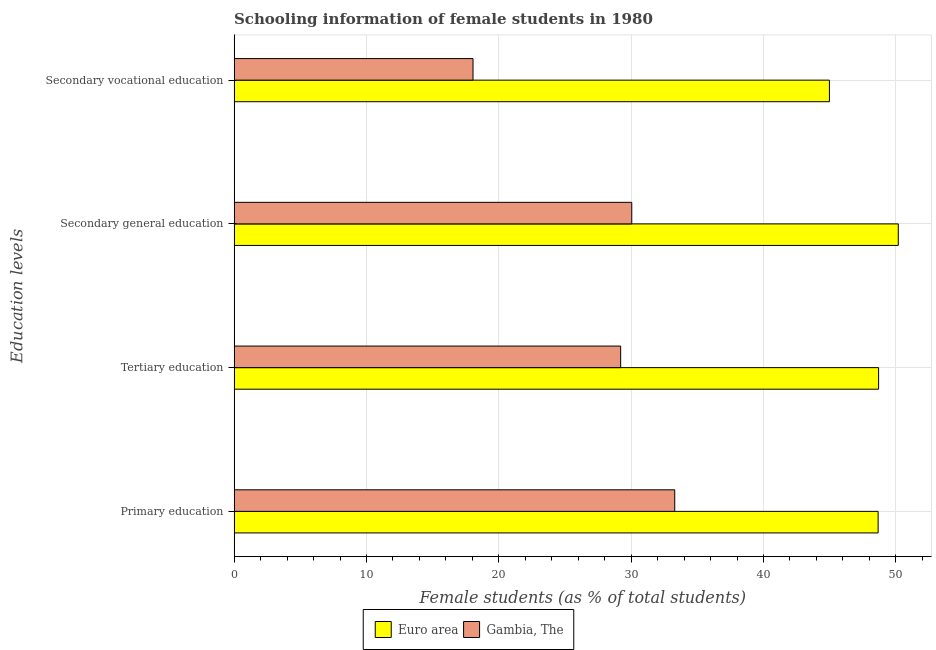How many different coloured bars are there?
Give a very brief answer. 2. How many groups of bars are there?
Offer a very short reply. 4. Are the number of bars per tick equal to the number of legend labels?
Give a very brief answer. Yes. How many bars are there on the 1st tick from the top?
Offer a terse response. 2. How many bars are there on the 4th tick from the bottom?
Provide a succinct answer. 2. What is the label of the 3rd group of bars from the top?
Provide a short and direct response. Tertiary education. What is the percentage of female students in primary education in Euro area?
Your answer should be very brief. 48.66. Across all countries, what is the maximum percentage of female students in secondary education?
Provide a succinct answer. 50.18. Across all countries, what is the minimum percentage of female students in secondary education?
Provide a succinct answer. 30.05. In which country was the percentage of female students in primary education minimum?
Your answer should be very brief. Gambia, The. What is the total percentage of female students in secondary vocational education in the graph?
Your answer should be very brief. 63.03. What is the difference between the percentage of female students in tertiary education in Euro area and that in Gambia, The?
Offer a very short reply. 19.49. What is the difference between the percentage of female students in primary education in Gambia, The and the percentage of female students in secondary education in Euro area?
Offer a very short reply. -16.89. What is the average percentage of female students in secondary vocational education per country?
Make the answer very short. 31.52. What is the difference between the percentage of female students in secondary vocational education and percentage of female students in primary education in Euro area?
Provide a short and direct response. -3.68. What is the ratio of the percentage of female students in tertiary education in Euro area to that in Gambia, The?
Offer a terse response. 1.67. Is the percentage of female students in tertiary education in Gambia, The less than that in Euro area?
Your answer should be compact. Yes. Is the difference between the percentage of female students in tertiary education in Gambia, The and Euro area greater than the difference between the percentage of female students in secondary vocational education in Gambia, The and Euro area?
Keep it short and to the point. Yes. What is the difference between the highest and the second highest percentage of female students in secondary education?
Keep it short and to the point. 20.14. What is the difference between the highest and the lowest percentage of female students in primary education?
Make the answer very short. 15.37. Is the sum of the percentage of female students in tertiary education in Euro area and Gambia, The greater than the maximum percentage of female students in primary education across all countries?
Your answer should be very brief. Yes. Is it the case that in every country, the sum of the percentage of female students in secondary education and percentage of female students in primary education is greater than the sum of percentage of female students in secondary vocational education and percentage of female students in tertiary education?
Provide a short and direct response. Yes. What does the 1st bar from the top in Secondary vocational education represents?
Ensure brevity in your answer.  Gambia, The. What does the 2nd bar from the bottom in Primary education represents?
Make the answer very short. Gambia, The. How many bars are there?
Your answer should be very brief. 8. Does the graph contain any zero values?
Your answer should be very brief. No. What is the title of the graph?
Your response must be concise. Schooling information of female students in 1980. Does "Pakistan" appear as one of the legend labels in the graph?
Ensure brevity in your answer.  No. What is the label or title of the X-axis?
Ensure brevity in your answer.  Female students (as % of total students). What is the label or title of the Y-axis?
Your response must be concise. Education levels. What is the Female students (as % of total students) in Euro area in Primary education?
Provide a short and direct response. 48.66. What is the Female students (as % of total students) in Gambia, The in Primary education?
Your answer should be compact. 33.29. What is the Female students (as % of total students) of Euro area in Tertiary education?
Your response must be concise. 48.7. What is the Female students (as % of total students) in Gambia, The in Tertiary education?
Provide a short and direct response. 29.21. What is the Female students (as % of total students) in Euro area in Secondary general education?
Give a very brief answer. 50.18. What is the Female students (as % of total students) of Gambia, The in Secondary general education?
Your response must be concise. 30.05. What is the Female students (as % of total students) in Euro area in Secondary vocational education?
Give a very brief answer. 44.98. What is the Female students (as % of total students) of Gambia, The in Secondary vocational education?
Make the answer very short. 18.05. Across all Education levels, what is the maximum Female students (as % of total students) in Euro area?
Ensure brevity in your answer.  50.18. Across all Education levels, what is the maximum Female students (as % of total students) of Gambia, The?
Provide a succinct answer. 33.29. Across all Education levels, what is the minimum Female students (as % of total students) of Euro area?
Provide a short and direct response. 44.98. Across all Education levels, what is the minimum Female students (as % of total students) in Gambia, The?
Your answer should be compact. 18.05. What is the total Female students (as % of total students) in Euro area in the graph?
Make the answer very short. 192.52. What is the total Female students (as % of total students) in Gambia, The in the graph?
Offer a very short reply. 110.6. What is the difference between the Female students (as % of total students) in Euro area in Primary education and that in Tertiary education?
Your answer should be compact. -0.03. What is the difference between the Female students (as % of total students) in Gambia, The in Primary education and that in Tertiary education?
Offer a terse response. 4.09. What is the difference between the Female students (as % of total students) in Euro area in Primary education and that in Secondary general education?
Ensure brevity in your answer.  -1.52. What is the difference between the Female students (as % of total students) of Gambia, The in Primary education and that in Secondary general education?
Provide a succinct answer. 3.25. What is the difference between the Female students (as % of total students) of Euro area in Primary education and that in Secondary vocational education?
Your answer should be compact. 3.68. What is the difference between the Female students (as % of total students) in Gambia, The in Primary education and that in Secondary vocational education?
Make the answer very short. 15.24. What is the difference between the Female students (as % of total students) in Euro area in Tertiary education and that in Secondary general education?
Give a very brief answer. -1.49. What is the difference between the Female students (as % of total students) in Gambia, The in Tertiary education and that in Secondary general education?
Give a very brief answer. -0.84. What is the difference between the Female students (as % of total students) in Euro area in Tertiary education and that in Secondary vocational education?
Offer a very short reply. 3.72. What is the difference between the Female students (as % of total students) in Gambia, The in Tertiary education and that in Secondary vocational education?
Ensure brevity in your answer.  11.15. What is the difference between the Female students (as % of total students) of Euro area in Secondary general education and that in Secondary vocational education?
Give a very brief answer. 5.2. What is the difference between the Female students (as % of total students) in Gambia, The in Secondary general education and that in Secondary vocational education?
Your answer should be very brief. 11.99. What is the difference between the Female students (as % of total students) of Euro area in Primary education and the Female students (as % of total students) of Gambia, The in Tertiary education?
Offer a very short reply. 19.46. What is the difference between the Female students (as % of total students) in Euro area in Primary education and the Female students (as % of total students) in Gambia, The in Secondary general education?
Provide a short and direct response. 18.62. What is the difference between the Female students (as % of total students) in Euro area in Primary education and the Female students (as % of total students) in Gambia, The in Secondary vocational education?
Your answer should be compact. 30.61. What is the difference between the Female students (as % of total students) of Euro area in Tertiary education and the Female students (as % of total students) of Gambia, The in Secondary general education?
Your answer should be compact. 18.65. What is the difference between the Female students (as % of total students) of Euro area in Tertiary education and the Female students (as % of total students) of Gambia, The in Secondary vocational education?
Your answer should be compact. 30.64. What is the difference between the Female students (as % of total students) in Euro area in Secondary general education and the Female students (as % of total students) in Gambia, The in Secondary vocational education?
Offer a terse response. 32.13. What is the average Female students (as % of total students) in Euro area per Education levels?
Provide a short and direct response. 48.13. What is the average Female students (as % of total students) of Gambia, The per Education levels?
Keep it short and to the point. 27.65. What is the difference between the Female students (as % of total students) in Euro area and Female students (as % of total students) in Gambia, The in Primary education?
Provide a short and direct response. 15.37. What is the difference between the Female students (as % of total students) in Euro area and Female students (as % of total students) in Gambia, The in Tertiary education?
Your response must be concise. 19.49. What is the difference between the Female students (as % of total students) of Euro area and Female students (as % of total students) of Gambia, The in Secondary general education?
Keep it short and to the point. 20.14. What is the difference between the Female students (as % of total students) of Euro area and Female students (as % of total students) of Gambia, The in Secondary vocational education?
Keep it short and to the point. 26.93. What is the ratio of the Female students (as % of total students) in Euro area in Primary education to that in Tertiary education?
Provide a short and direct response. 1. What is the ratio of the Female students (as % of total students) of Gambia, The in Primary education to that in Tertiary education?
Offer a terse response. 1.14. What is the ratio of the Female students (as % of total students) of Euro area in Primary education to that in Secondary general education?
Your response must be concise. 0.97. What is the ratio of the Female students (as % of total students) in Gambia, The in Primary education to that in Secondary general education?
Your answer should be compact. 1.11. What is the ratio of the Female students (as % of total students) in Euro area in Primary education to that in Secondary vocational education?
Give a very brief answer. 1.08. What is the ratio of the Female students (as % of total students) in Gambia, The in Primary education to that in Secondary vocational education?
Provide a succinct answer. 1.84. What is the ratio of the Female students (as % of total students) in Euro area in Tertiary education to that in Secondary general education?
Make the answer very short. 0.97. What is the ratio of the Female students (as % of total students) of Euro area in Tertiary education to that in Secondary vocational education?
Provide a short and direct response. 1.08. What is the ratio of the Female students (as % of total students) of Gambia, The in Tertiary education to that in Secondary vocational education?
Your answer should be compact. 1.62. What is the ratio of the Female students (as % of total students) of Euro area in Secondary general education to that in Secondary vocational education?
Offer a terse response. 1.12. What is the ratio of the Female students (as % of total students) in Gambia, The in Secondary general education to that in Secondary vocational education?
Offer a terse response. 1.66. What is the difference between the highest and the second highest Female students (as % of total students) of Euro area?
Your answer should be very brief. 1.49. What is the difference between the highest and the second highest Female students (as % of total students) of Gambia, The?
Keep it short and to the point. 3.25. What is the difference between the highest and the lowest Female students (as % of total students) of Euro area?
Provide a succinct answer. 5.2. What is the difference between the highest and the lowest Female students (as % of total students) in Gambia, The?
Provide a succinct answer. 15.24. 